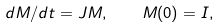Convert formula to latex. <formula><loc_0><loc_0><loc_500><loc_500>d { M } / d t = { J } { M } , \quad { M } ( 0 ) = { I } ,</formula> 